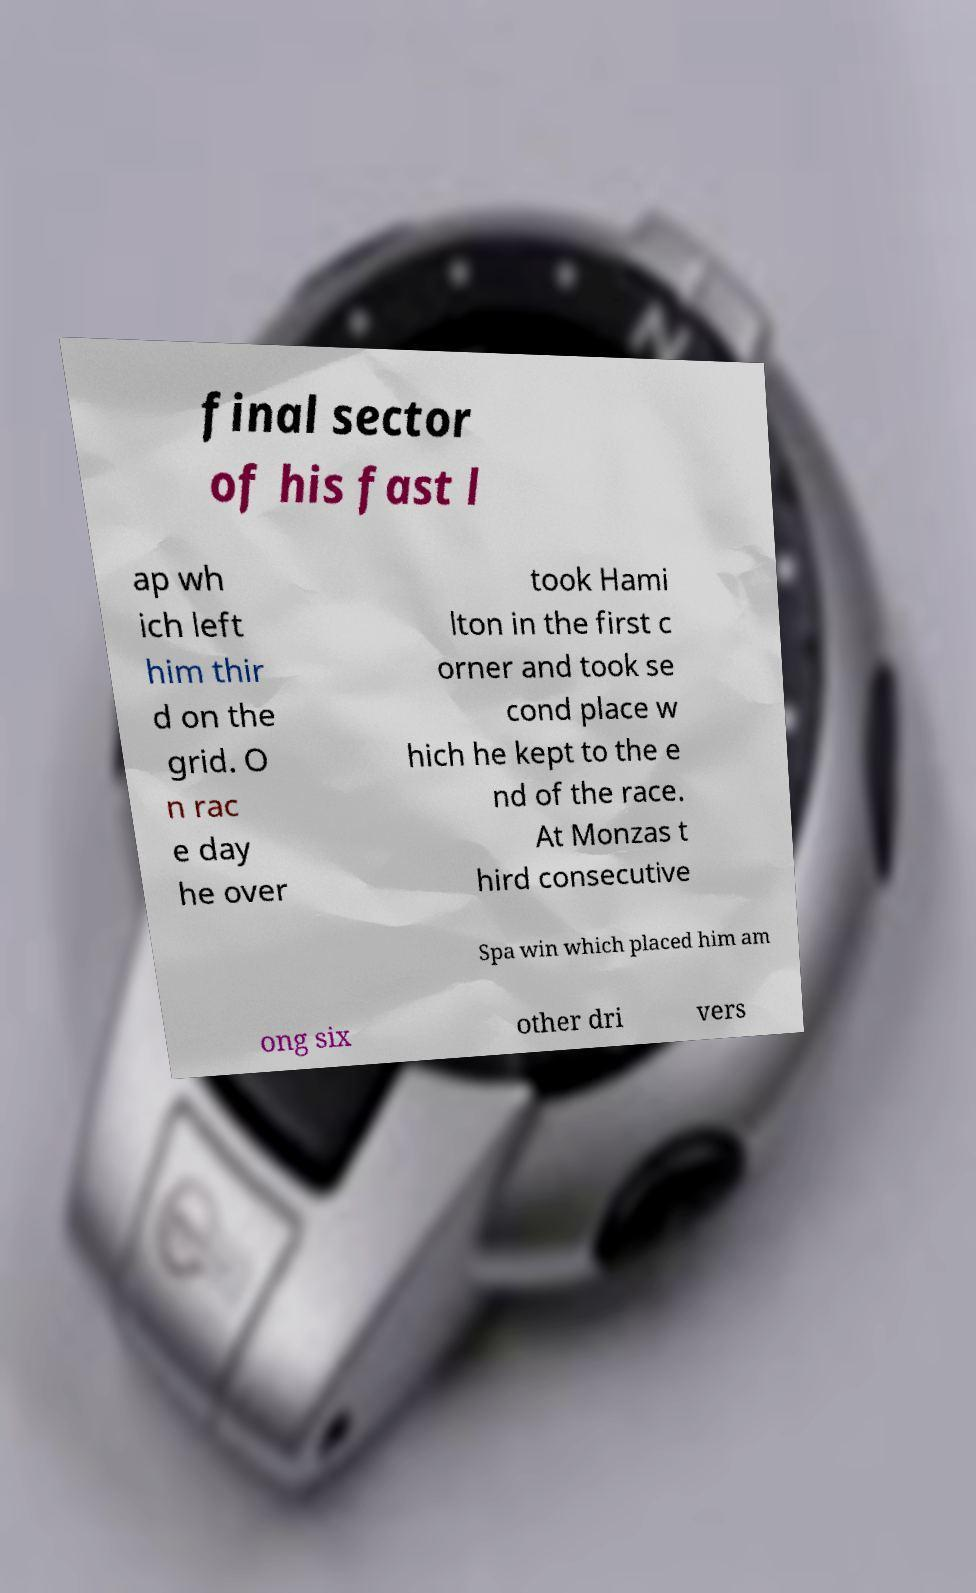There's text embedded in this image that I need extracted. Can you transcribe it verbatim? final sector of his fast l ap wh ich left him thir d on the grid. O n rac e day he over took Hami lton in the first c orner and took se cond place w hich he kept to the e nd of the race. At Monzas t hird consecutive Spa win which placed him am ong six other dri vers 